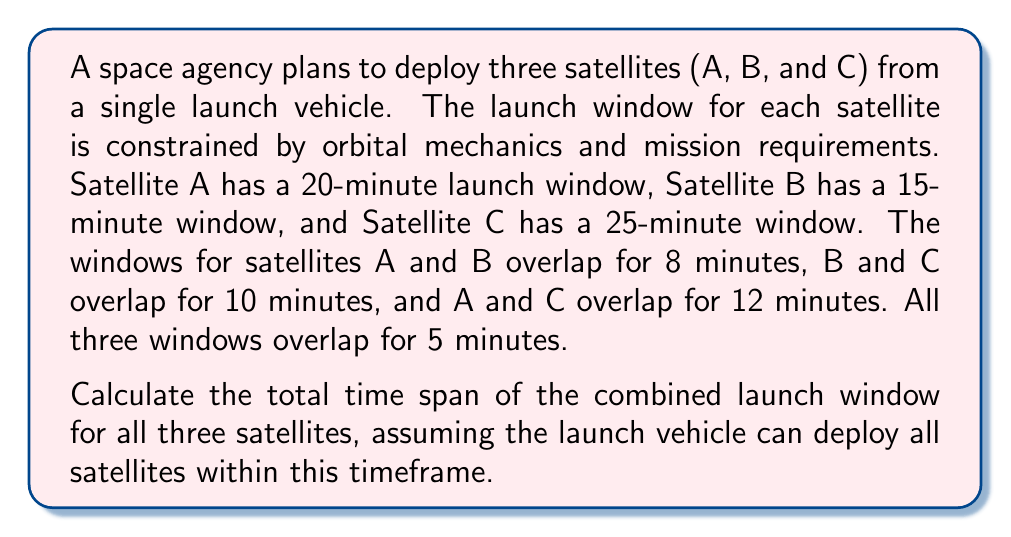Show me your answer to this math problem. To solve this problem, we'll use the principle of inclusion-exclusion from set theory. Let's define the following:

$A$: Launch window for Satellite A (20 minutes)
$B$: Launch window for Satellite B (15 minutes)
$C$: Launch window for Satellite C (25 minutes)

We need to find $|A \cup B \cup C|$, which is the total time span of the combined launch window.

The inclusion-exclusion principle states:

$$|A \cup B \cup C| = |A| + |B| + |C| - |A \cap B| - |B \cap C| - |A \cap C| + |A \cap B \cap C|$$

We know:
$|A| = 20$
$|B| = 15$
$|C| = 25$
$|A \cap B| = 8$
$|B \cap C| = 10$
$|A \cap C| = 12$
$|A \cap B \cap C| = 5$

Substituting these values into the equation:

$$|A \cup B \cup C| = 20 + 15 + 25 - 8 - 10 - 12 + 5$$

$$|A \cup B \cup C| = 60 - 30 + 5$$

$$|A \cup B \cup C| = 35$$

Therefore, the total time span of the combined launch window for all three satellites is 35 minutes.
Answer: 35 minutes 